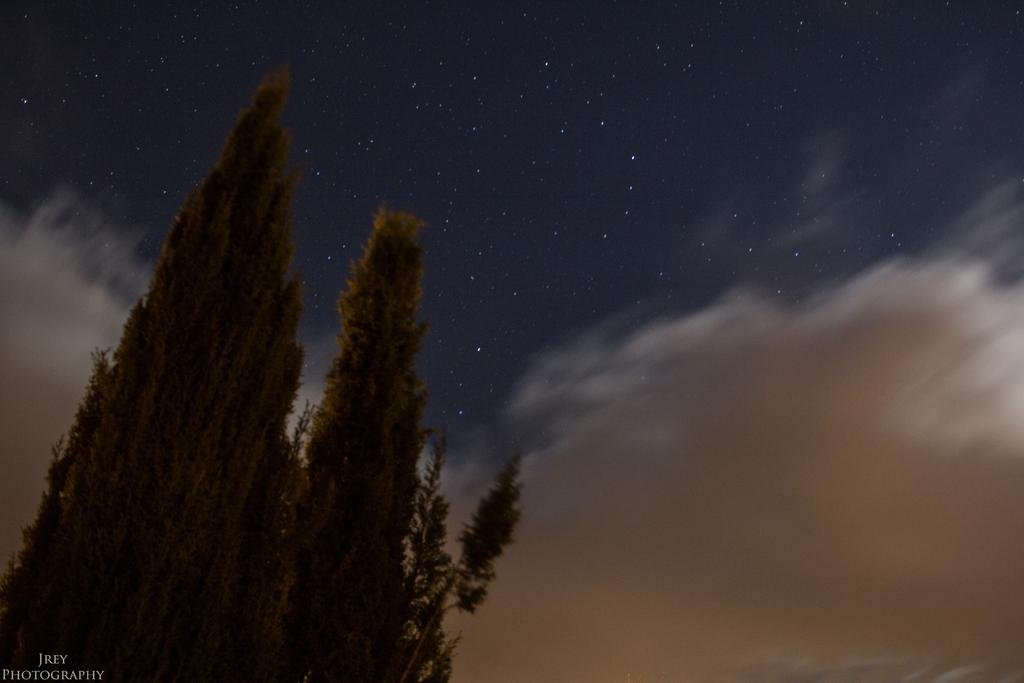What type of vegetation is on the left side of the image? There are trees on the left side of the image. What is visible in the image besides the trees? The sky is visible in the image. Can you describe the sky in the image? The sky has clouds in the image. Are there any celestial bodies visible in the sky? Yes, there are stars in the sky. How many times did the person attempt to open the gate in the image? There is no gate present in the image, so it is not possible to answer that question. 